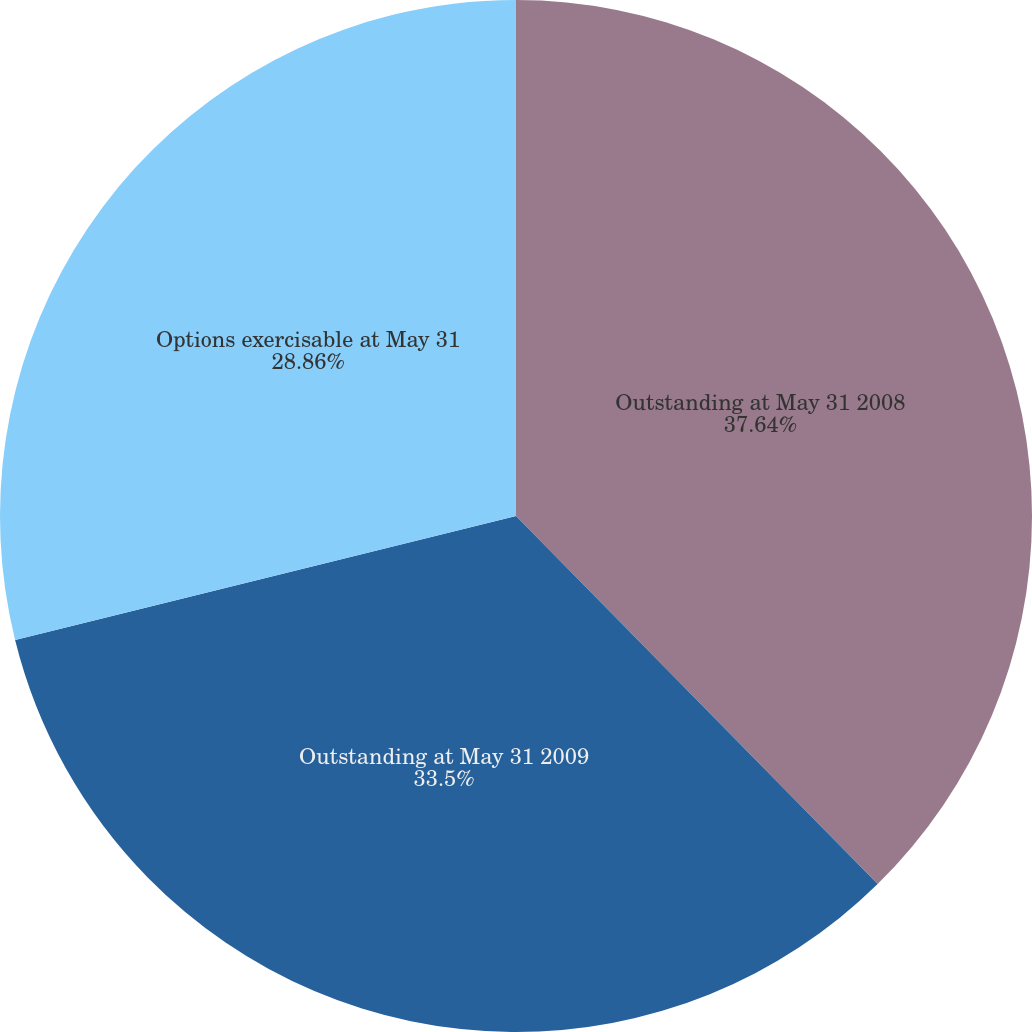Convert chart. <chart><loc_0><loc_0><loc_500><loc_500><pie_chart><fcel>Outstanding at May 31 2008<fcel>Outstanding at May 31 2009<fcel>Options exercisable at May 31<nl><fcel>37.64%<fcel>33.5%<fcel>28.86%<nl></chart> 